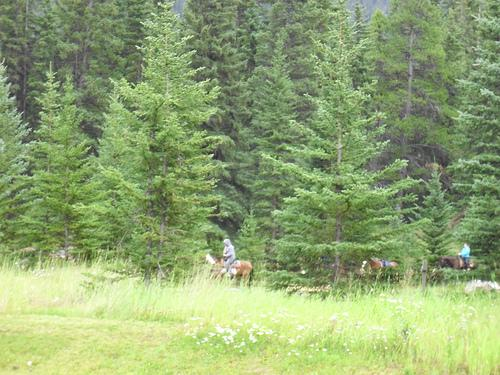As a group, what are the people in the picture doing? The people in the picture are going on a trail ride on brown horses, with one person on a black horse. Which object is the tallest in the image? The large group of trees seems to be the tallest object in the image. Enumerate the prominent elements found in the image. Riders on brown horses, green leaves, pine trees, white flowers, tall green grass, and a tall skinny tree branch. What kind of animals can be found in this picture? There are brown horses, with one having a black tail, and a black horse is present in the back. Analyze the sentiment of the image. The sentiment of the image is peaceful and serene, with riders enjoying a trail ride in a beautiful forest setting. Count the number of riders and horses in the image. There are nine riders on horses, with eight on brown horses and one on a black horse. Provide a detailed account of the environment depicted in the image. The scene appears to be a forest with a mix of pine trees, brown trees with green leaves, tall green grass, and some white flowers in the grass. Several riders on brown horses are present, with one black horse in the back. Identify the main activities taking place in the image. Riders are riding brown horses among pine trees and green leaves, while white flowers can be found in the grass. What is the overall quality of the image in terms of clarity and focus? The overall quality of the image is clear, as all objects are well-defined, mostly focused, and have a detailed description of their positions and sizes. Describe a notable object interaction in the image. A rider on a brown horse interacts with green leaves and pine trees as they navigate through the forest trail. Is there a pine tree with purple leaves at X:0 Y:56 with Width:35 and Height:35? The object at this position is a pine tree in a forest with regular green leaves, not purple leaves. Can you find tall orange grass at X:0 Y:252 with Width:344 and Height:344? The object at this position is tall green grass, not orange grass. Do you see a small group of purple flowers at X:447 Y:265 with Width:51 and Height:51? The object at this position is a small group of white flowers, not purple flowers. Is there a tall fat tree branch at X:327 Y:101 with Width:30 and Height:30? The object at this position is a tall skinny tree branch, not a fat tree branch. Is there a rider on a black horse at X:39 Y:217 with Width:54 and Height:54? The object at this position is a rider on a brown horse, not a black horse. Can you locate green leaves in blue trees at X:99 Y:116 with Width:72 and Height:72? The object at this position has green leaves in brown trees, not blue trees. 